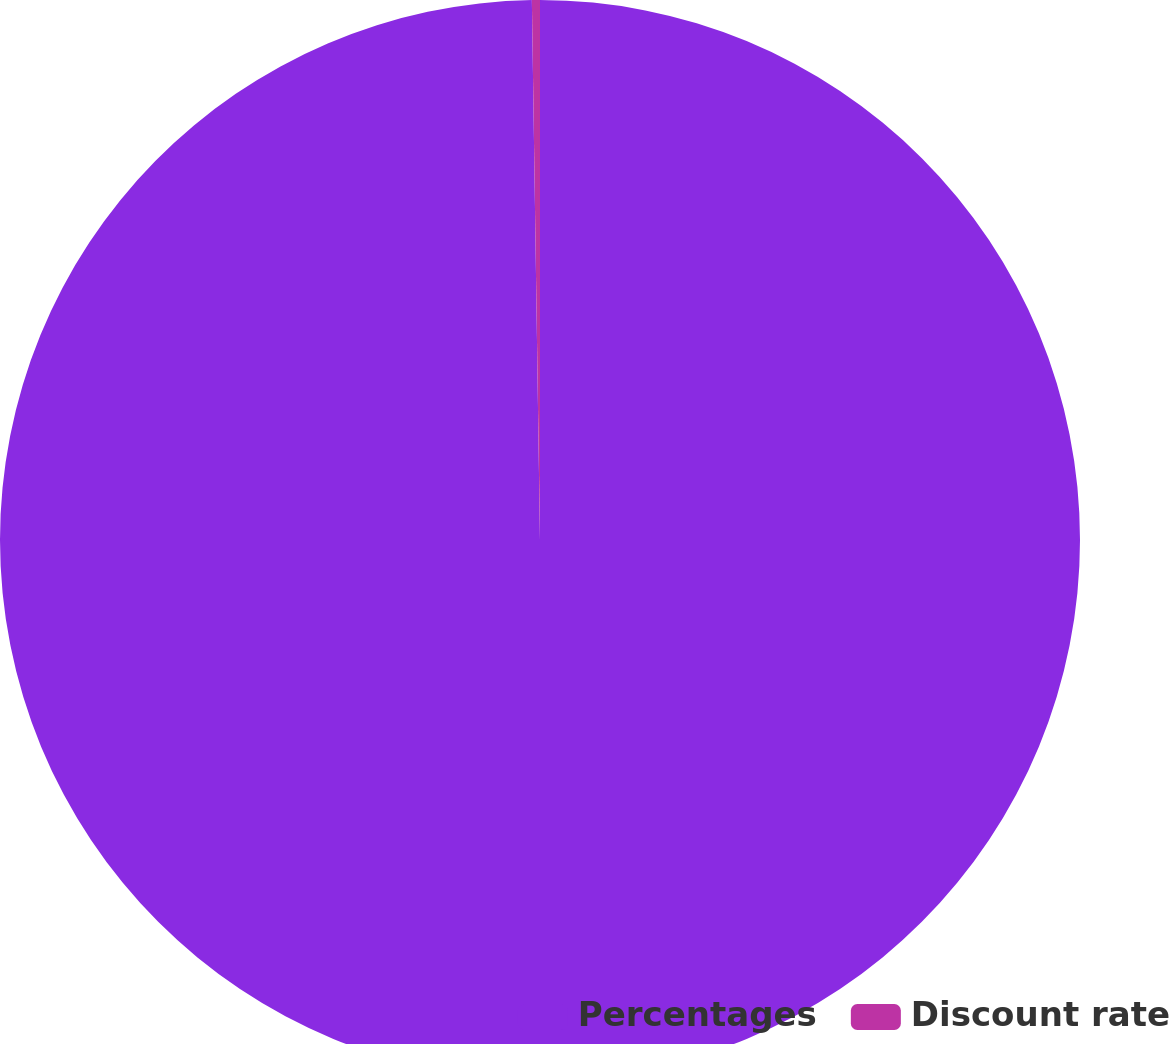Convert chart to OTSL. <chart><loc_0><loc_0><loc_500><loc_500><pie_chart><fcel>Percentages<fcel>Discount rate<nl><fcel>99.76%<fcel>0.24%<nl></chart> 